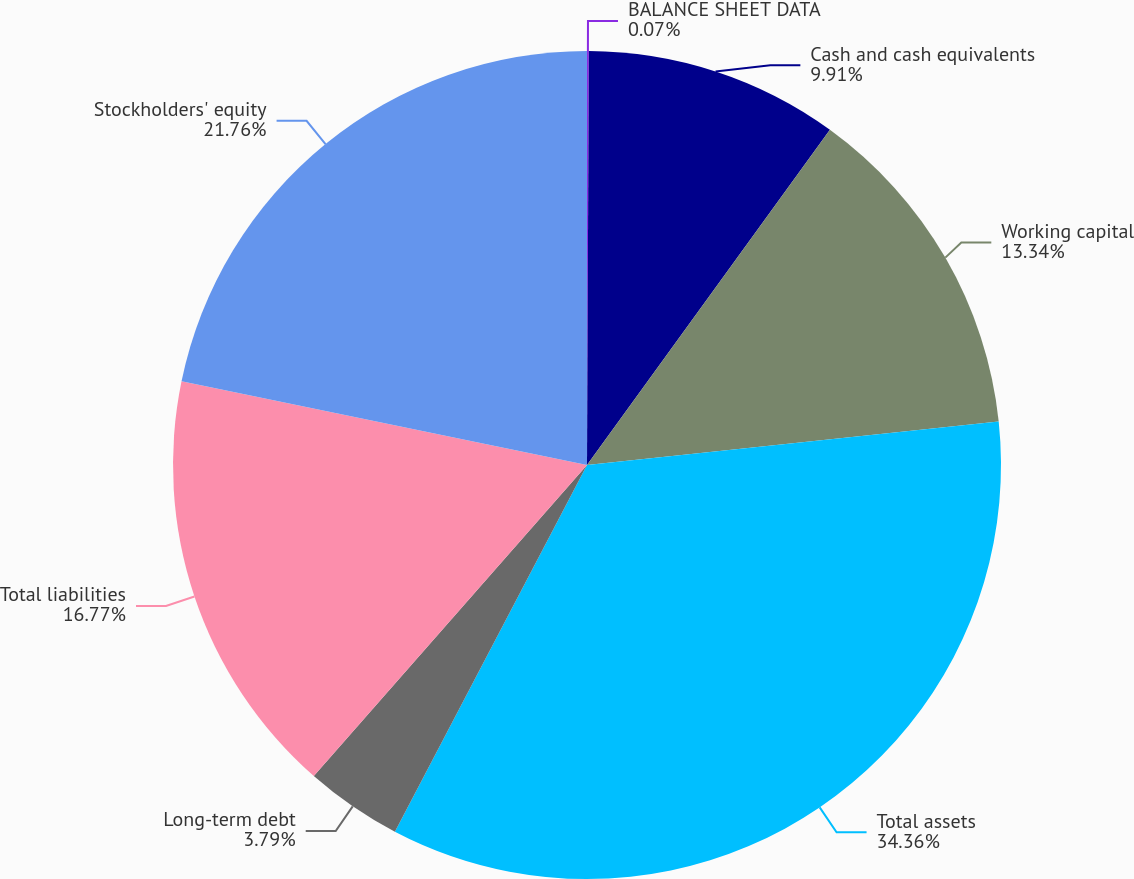Convert chart to OTSL. <chart><loc_0><loc_0><loc_500><loc_500><pie_chart><fcel>BALANCE SHEET DATA<fcel>Cash and cash equivalents<fcel>Working capital<fcel>Total assets<fcel>Long-term debt<fcel>Total liabilities<fcel>Stockholders' equity<nl><fcel>0.07%<fcel>9.91%<fcel>13.34%<fcel>34.36%<fcel>3.79%<fcel>16.77%<fcel>21.76%<nl></chart> 